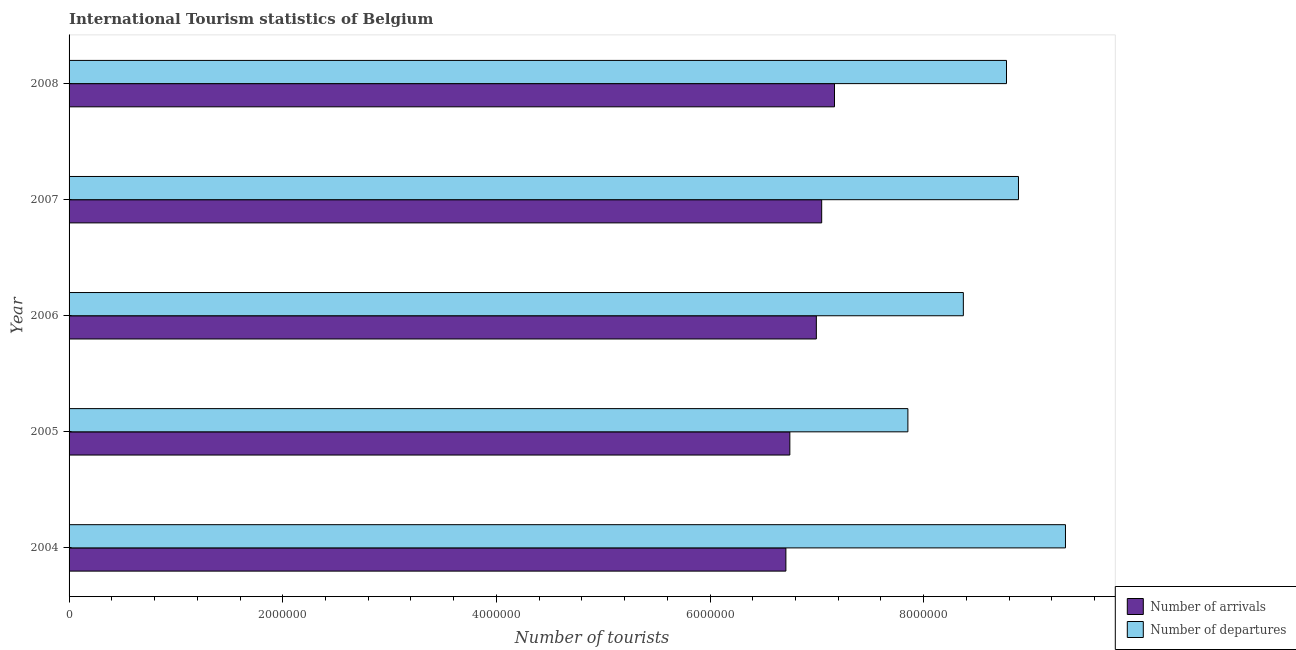How many groups of bars are there?
Give a very brief answer. 5. How many bars are there on the 2nd tick from the bottom?
Offer a very short reply. 2. What is the label of the 5th group of bars from the top?
Your answer should be very brief. 2004. In how many cases, is the number of bars for a given year not equal to the number of legend labels?
Keep it short and to the point. 0. What is the number of tourist departures in 2006?
Your answer should be very brief. 8.37e+06. Across all years, what is the maximum number of tourist arrivals?
Your answer should be compact. 7.16e+06. Across all years, what is the minimum number of tourist arrivals?
Your answer should be compact. 6.71e+06. In which year was the number of tourist departures maximum?
Ensure brevity in your answer.  2004. In which year was the number of tourist departures minimum?
Your response must be concise. 2005. What is the total number of tourist departures in the graph?
Make the answer very short. 4.32e+07. What is the difference between the number of tourist departures in 2006 and that in 2008?
Offer a very short reply. -4.04e+05. What is the difference between the number of tourist departures in 2004 and the number of tourist arrivals in 2005?
Offer a terse response. 2.58e+06. What is the average number of tourist departures per year?
Offer a terse response. 8.64e+06. In the year 2008, what is the difference between the number of tourist departures and number of tourist arrivals?
Offer a very short reply. 1.61e+06. What is the ratio of the number of tourist arrivals in 2004 to that in 2008?
Provide a succinct answer. 0.94. Is the difference between the number of tourist arrivals in 2005 and 2006 greater than the difference between the number of tourist departures in 2005 and 2006?
Make the answer very short. Yes. What is the difference between the highest and the second highest number of tourist departures?
Offer a terse response. 4.40e+05. What is the difference between the highest and the lowest number of tourist departures?
Offer a very short reply. 1.48e+06. In how many years, is the number of tourist arrivals greater than the average number of tourist arrivals taken over all years?
Offer a very short reply. 3. Is the sum of the number of tourist departures in 2005 and 2006 greater than the maximum number of tourist arrivals across all years?
Give a very brief answer. Yes. What does the 2nd bar from the top in 2008 represents?
Offer a very short reply. Number of arrivals. What does the 1st bar from the bottom in 2005 represents?
Your answer should be compact. Number of arrivals. Are all the bars in the graph horizontal?
Keep it short and to the point. Yes. How many years are there in the graph?
Offer a very short reply. 5. What is the difference between two consecutive major ticks on the X-axis?
Your answer should be very brief. 2.00e+06. Are the values on the major ticks of X-axis written in scientific E-notation?
Offer a very short reply. No. Does the graph contain grids?
Give a very brief answer. No. Where does the legend appear in the graph?
Ensure brevity in your answer.  Bottom right. How are the legend labels stacked?
Your response must be concise. Vertical. What is the title of the graph?
Offer a terse response. International Tourism statistics of Belgium. What is the label or title of the X-axis?
Your response must be concise. Number of tourists. What is the Number of tourists in Number of arrivals in 2004?
Keep it short and to the point. 6.71e+06. What is the Number of tourists of Number of departures in 2004?
Your answer should be very brief. 9.33e+06. What is the Number of tourists of Number of arrivals in 2005?
Offer a terse response. 6.75e+06. What is the Number of tourists of Number of departures in 2005?
Ensure brevity in your answer.  7.85e+06. What is the Number of tourists of Number of arrivals in 2006?
Ensure brevity in your answer.  7.00e+06. What is the Number of tourists of Number of departures in 2006?
Make the answer very short. 8.37e+06. What is the Number of tourists of Number of arrivals in 2007?
Your answer should be compact. 7.04e+06. What is the Number of tourists of Number of departures in 2007?
Give a very brief answer. 8.89e+06. What is the Number of tourists in Number of arrivals in 2008?
Your answer should be very brief. 7.16e+06. What is the Number of tourists of Number of departures in 2008?
Provide a short and direct response. 8.78e+06. Across all years, what is the maximum Number of tourists of Number of arrivals?
Give a very brief answer. 7.16e+06. Across all years, what is the maximum Number of tourists of Number of departures?
Give a very brief answer. 9.33e+06. Across all years, what is the minimum Number of tourists of Number of arrivals?
Offer a very short reply. 6.71e+06. Across all years, what is the minimum Number of tourists of Number of departures?
Ensure brevity in your answer.  7.85e+06. What is the total Number of tourists in Number of arrivals in the graph?
Your answer should be compact. 3.47e+07. What is the total Number of tourists in Number of departures in the graph?
Ensure brevity in your answer.  4.32e+07. What is the difference between the Number of tourists of Number of arrivals in 2004 and that in 2005?
Make the answer very short. -3.70e+04. What is the difference between the Number of tourists in Number of departures in 2004 and that in 2005?
Ensure brevity in your answer.  1.48e+06. What is the difference between the Number of tourists of Number of arrivals in 2004 and that in 2006?
Provide a succinct answer. -2.85e+05. What is the difference between the Number of tourists of Number of departures in 2004 and that in 2006?
Your answer should be very brief. 9.56e+05. What is the difference between the Number of tourists of Number of arrivals in 2004 and that in 2007?
Your answer should be compact. -3.35e+05. What is the difference between the Number of tourists in Number of departures in 2004 and that in 2007?
Provide a succinct answer. 4.40e+05. What is the difference between the Number of tourists in Number of arrivals in 2004 and that in 2008?
Provide a short and direct response. -4.55e+05. What is the difference between the Number of tourists of Number of departures in 2004 and that in 2008?
Your answer should be very brief. 5.52e+05. What is the difference between the Number of tourists of Number of arrivals in 2005 and that in 2006?
Provide a succinct answer. -2.48e+05. What is the difference between the Number of tourists of Number of departures in 2005 and that in 2006?
Provide a succinct answer. -5.19e+05. What is the difference between the Number of tourists of Number of arrivals in 2005 and that in 2007?
Offer a terse response. -2.98e+05. What is the difference between the Number of tourists of Number of departures in 2005 and that in 2007?
Your answer should be compact. -1.04e+06. What is the difference between the Number of tourists of Number of arrivals in 2005 and that in 2008?
Offer a very short reply. -4.18e+05. What is the difference between the Number of tourists in Number of departures in 2005 and that in 2008?
Your answer should be compact. -9.23e+05. What is the difference between the Number of tourists of Number of departures in 2006 and that in 2007?
Ensure brevity in your answer.  -5.16e+05. What is the difference between the Number of tourists in Number of arrivals in 2006 and that in 2008?
Offer a terse response. -1.70e+05. What is the difference between the Number of tourists of Number of departures in 2006 and that in 2008?
Ensure brevity in your answer.  -4.04e+05. What is the difference between the Number of tourists of Number of arrivals in 2007 and that in 2008?
Keep it short and to the point. -1.20e+05. What is the difference between the Number of tourists in Number of departures in 2007 and that in 2008?
Provide a succinct answer. 1.12e+05. What is the difference between the Number of tourists of Number of arrivals in 2004 and the Number of tourists of Number of departures in 2005?
Keep it short and to the point. -1.14e+06. What is the difference between the Number of tourists of Number of arrivals in 2004 and the Number of tourists of Number of departures in 2006?
Provide a succinct answer. -1.66e+06. What is the difference between the Number of tourists in Number of arrivals in 2004 and the Number of tourists in Number of departures in 2007?
Offer a terse response. -2.18e+06. What is the difference between the Number of tourists in Number of arrivals in 2004 and the Number of tourists in Number of departures in 2008?
Offer a very short reply. -2.06e+06. What is the difference between the Number of tourists of Number of arrivals in 2005 and the Number of tourists of Number of departures in 2006?
Offer a terse response. -1.62e+06. What is the difference between the Number of tourists of Number of arrivals in 2005 and the Number of tourists of Number of departures in 2007?
Your answer should be very brief. -2.14e+06. What is the difference between the Number of tourists in Number of arrivals in 2005 and the Number of tourists in Number of departures in 2008?
Your answer should be compact. -2.03e+06. What is the difference between the Number of tourists in Number of arrivals in 2006 and the Number of tourists in Number of departures in 2007?
Provide a succinct answer. -1.89e+06. What is the difference between the Number of tourists in Number of arrivals in 2006 and the Number of tourists in Number of departures in 2008?
Keep it short and to the point. -1.78e+06. What is the difference between the Number of tourists in Number of arrivals in 2007 and the Number of tourists in Number of departures in 2008?
Give a very brief answer. -1.73e+06. What is the average Number of tourists in Number of arrivals per year?
Offer a terse response. 6.93e+06. What is the average Number of tourists of Number of departures per year?
Offer a terse response. 8.64e+06. In the year 2004, what is the difference between the Number of tourists in Number of arrivals and Number of tourists in Number of departures?
Ensure brevity in your answer.  -2.62e+06. In the year 2005, what is the difference between the Number of tourists in Number of arrivals and Number of tourists in Number of departures?
Offer a very short reply. -1.10e+06. In the year 2006, what is the difference between the Number of tourists in Number of arrivals and Number of tourists in Number of departures?
Provide a succinct answer. -1.38e+06. In the year 2007, what is the difference between the Number of tourists of Number of arrivals and Number of tourists of Number of departures?
Offer a very short reply. -1.84e+06. In the year 2008, what is the difference between the Number of tourists in Number of arrivals and Number of tourists in Number of departures?
Make the answer very short. -1.61e+06. What is the ratio of the Number of tourists of Number of arrivals in 2004 to that in 2005?
Ensure brevity in your answer.  0.99. What is the ratio of the Number of tourists in Number of departures in 2004 to that in 2005?
Provide a short and direct response. 1.19. What is the ratio of the Number of tourists of Number of arrivals in 2004 to that in 2006?
Give a very brief answer. 0.96. What is the ratio of the Number of tourists in Number of departures in 2004 to that in 2006?
Provide a short and direct response. 1.11. What is the ratio of the Number of tourists of Number of departures in 2004 to that in 2007?
Offer a very short reply. 1.05. What is the ratio of the Number of tourists of Number of arrivals in 2004 to that in 2008?
Your answer should be compact. 0.94. What is the ratio of the Number of tourists in Number of departures in 2004 to that in 2008?
Offer a very short reply. 1.06. What is the ratio of the Number of tourists in Number of arrivals in 2005 to that in 2006?
Give a very brief answer. 0.96. What is the ratio of the Number of tourists in Number of departures in 2005 to that in 2006?
Provide a short and direct response. 0.94. What is the ratio of the Number of tourists in Number of arrivals in 2005 to that in 2007?
Ensure brevity in your answer.  0.96. What is the ratio of the Number of tourists of Number of departures in 2005 to that in 2007?
Offer a terse response. 0.88. What is the ratio of the Number of tourists in Number of arrivals in 2005 to that in 2008?
Ensure brevity in your answer.  0.94. What is the ratio of the Number of tourists in Number of departures in 2005 to that in 2008?
Your answer should be very brief. 0.89. What is the ratio of the Number of tourists in Number of arrivals in 2006 to that in 2007?
Provide a short and direct response. 0.99. What is the ratio of the Number of tourists of Number of departures in 2006 to that in 2007?
Your answer should be compact. 0.94. What is the ratio of the Number of tourists of Number of arrivals in 2006 to that in 2008?
Your answer should be compact. 0.98. What is the ratio of the Number of tourists of Number of departures in 2006 to that in 2008?
Make the answer very short. 0.95. What is the ratio of the Number of tourists of Number of arrivals in 2007 to that in 2008?
Give a very brief answer. 0.98. What is the ratio of the Number of tourists in Number of departures in 2007 to that in 2008?
Make the answer very short. 1.01. What is the difference between the highest and the second highest Number of tourists of Number of departures?
Your answer should be compact. 4.40e+05. What is the difference between the highest and the lowest Number of tourists of Number of arrivals?
Your answer should be very brief. 4.55e+05. What is the difference between the highest and the lowest Number of tourists of Number of departures?
Your response must be concise. 1.48e+06. 